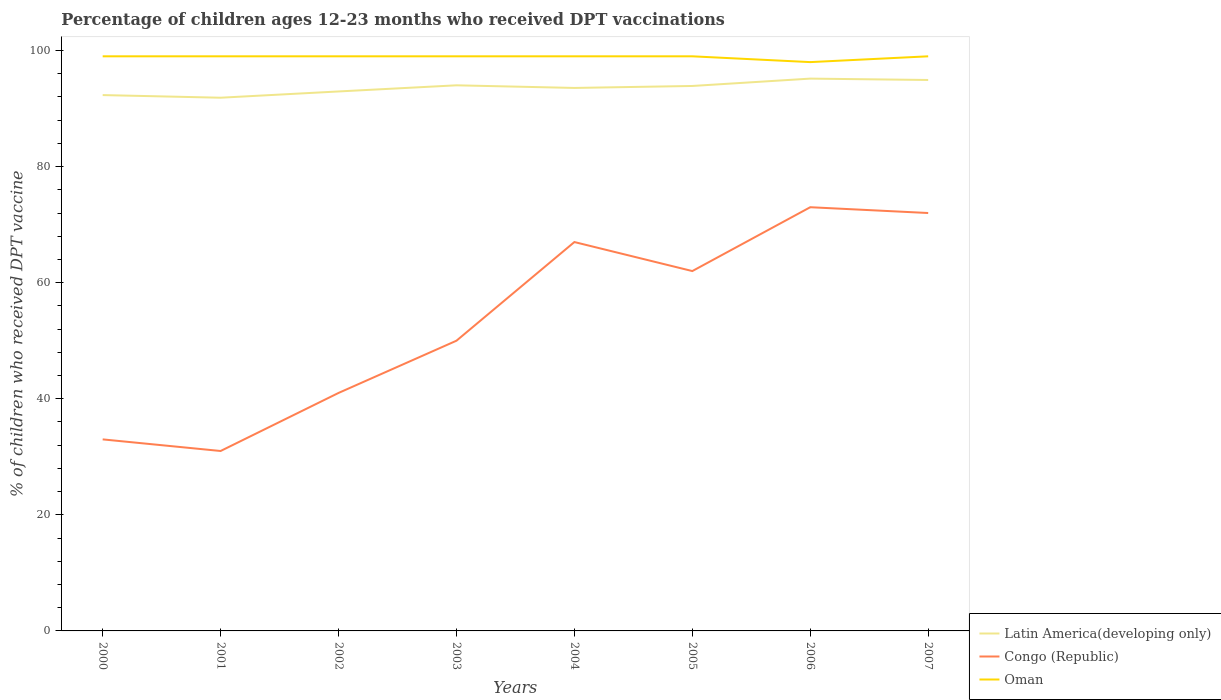Does the line corresponding to Oman intersect with the line corresponding to Latin America(developing only)?
Your response must be concise. No. Is the number of lines equal to the number of legend labels?
Provide a short and direct response. Yes. Across all years, what is the maximum percentage of children who received DPT vaccination in Latin America(developing only)?
Your answer should be very brief. 91.87. In which year was the percentage of children who received DPT vaccination in Congo (Republic) maximum?
Offer a very short reply. 2001. What is the total percentage of children who received DPT vaccination in Oman in the graph?
Provide a succinct answer. 0. What is the difference between the highest and the second highest percentage of children who received DPT vaccination in Congo (Republic)?
Offer a very short reply. 42. Is the percentage of children who received DPT vaccination in Congo (Republic) strictly greater than the percentage of children who received DPT vaccination in Oman over the years?
Your answer should be very brief. Yes. Where does the legend appear in the graph?
Your response must be concise. Bottom right. How many legend labels are there?
Your response must be concise. 3. How are the legend labels stacked?
Offer a terse response. Vertical. What is the title of the graph?
Offer a terse response. Percentage of children ages 12-23 months who received DPT vaccinations. What is the label or title of the X-axis?
Ensure brevity in your answer.  Years. What is the label or title of the Y-axis?
Make the answer very short. % of children who received DPT vaccine. What is the % of children who received DPT vaccine of Latin America(developing only) in 2000?
Keep it short and to the point. 92.32. What is the % of children who received DPT vaccine of Latin America(developing only) in 2001?
Keep it short and to the point. 91.87. What is the % of children who received DPT vaccine in Congo (Republic) in 2001?
Your answer should be very brief. 31. What is the % of children who received DPT vaccine in Oman in 2001?
Keep it short and to the point. 99. What is the % of children who received DPT vaccine of Latin America(developing only) in 2002?
Offer a very short reply. 92.95. What is the % of children who received DPT vaccine in Congo (Republic) in 2002?
Offer a very short reply. 41. What is the % of children who received DPT vaccine of Latin America(developing only) in 2003?
Ensure brevity in your answer.  94. What is the % of children who received DPT vaccine in Congo (Republic) in 2003?
Your answer should be very brief. 50. What is the % of children who received DPT vaccine of Latin America(developing only) in 2004?
Your response must be concise. 93.55. What is the % of children who received DPT vaccine of Congo (Republic) in 2004?
Ensure brevity in your answer.  67. What is the % of children who received DPT vaccine of Oman in 2004?
Your answer should be very brief. 99. What is the % of children who received DPT vaccine of Latin America(developing only) in 2005?
Your answer should be very brief. 93.89. What is the % of children who received DPT vaccine of Latin America(developing only) in 2006?
Your answer should be compact. 95.16. What is the % of children who received DPT vaccine in Congo (Republic) in 2006?
Keep it short and to the point. 73. What is the % of children who received DPT vaccine of Latin America(developing only) in 2007?
Make the answer very short. 94.92. What is the % of children who received DPT vaccine in Congo (Republic) in 2007?
Provide a succinct answer. 72. Across all years, what is the maximum % of children who received DPT vaccine of Latin America(developing only)?
Give a very brief answer. 95.16. Across all years, what is the maximum % of children who received DPT vaccine in Congo (Republic)?
Your answer should be very brief. 73. Across all years, what is the maximum % of children who received DPT vaccine of Oman?
Give a very brief answer. 99. Across all years, what is the minimum % of children who received DPT vaccine in Latin America(developing only)?
Offer a very short reply. 91.87. What is the total % of children who received DPT vaccine in Latin America(developing only) in the graph?
Ensure brevity in your answer.  748.66. What is the total % of children who received DPT vaccine of Congo (Republic) in the graph?
Ensure brevity in your answer.  429. What is the total % of children who received DPT vaccine of Oman in the graph?
Give a very brief answer. 791. What is the difference between the % of children who received DPT vaccine in Latin America(developing only) in 2000 and that in 2001?
Your response must be concise. 0.45. What is the difference between the % of children who received DPT vaccine of Congo (Republic) in 2000 and that in 2001?
Keep it short and to the point. 2. What is the difference between the % of children who received DPT vaccine in Oman in 2000 and that in 2001?
Offer a terse response. 0. What is the difference between the % of children who received DPT vaccine of Latin America(developing only) in 2000 and that in 2002?
Provide a succinct answer. -0.62. What is the difference between the % of children who received DPT vaccine in Congo (Republic) in 2000 and that in 2002?
Your response must be concise. -8. What is the difference between the % of children who received DPT vaccine of Latin America(developing only) in 2000 and that in 2003?
Make the answer very short. -1.68. What is the difference between the % of children who received DPT vaccine in Oman in 2000 and that in 2003?
Offer a very short reply. 0. What is the difference between the % of children who received DPT vaccine of Latin America(developing only) in 2000 and that in 2004?
Provide a short and direct response. -1.23. What is the difference between the % of children who received DPT vaccine in Congo (Republic) in 2000 and that in 2004?
Your answer should be compact. -34. What is the difference between the % of children who received DPT vaccine of Latin America(developing only) in 2000 and that in 2005?
Provide a succinct answer. -1.57. What is the difference between the % of children who received DPT vaccine in Congo (Republic) in 2000 and that in 2005?
Keep it short and to the point. -29. What is the difference between the % of children who received DPT vaccine of Oman in 2000 and that in 2005?
Your response must be concise. 0. What is the difference between the % of children who received DPT vaccine of Latin America(developing only) in 2000 and that in 2006?
Your response must be concise. -2.84. What is the difference between the % of children who received DPT vaccine in Oman in 2000 and that in 2006?
Make the answer very short. 1. What is the difference between the % of children who received DPT vaccine in Latin America(developing only) in 2000 and that in 2007?
Your answer should be compact. -2.6. What is the difference between the % of children who received DPT vaccine in Congo (Republic) in 2000 and that in 2007?
Provide a succinct answer. -39. What is the difference between the % of children who received DPT vaccine of Latin America(developing only) in 2001 and that in 2002?
Give a very brief answer. -1.08. What is the difference between the % of children who received DPT vaccine of Oman in 2001 and that in 2002?
Your answer should be very brief. 0. What is the difference between the % of children who received DPT vaccine of Latin America(developing only) in 2001 and that in 2003?
Your answer should be compact. -2.14. What is the difference between the % of children who received DPT vaccine of Oman in 2001 and that in 2003?
Offer a very short reply. 0. What is the difference between the % of children who received DPT vaccine of Latin America(developing only) in 2001 and that in 2004?
Make the answer very short. -1.68. What is the difference between the % of children who received DPT vaccine of Congo (Republic) in 2001 and that in 2004?
Give a very brief answer. -36. What is the difference between the % of children who received DPT vaccine of Oman in 2001 and that in 2004?
Offer a very short reply. 0. What is the difference between the % of children who received DPT vaccine in Latin America(developing only) in 2001 and that in 2005?
Give a very brief answer. -2.02. What is the difference between the % of children who received DPT vaccine in Congo (Republic) in 2001 and that in 2005?
Your answer should be very brief. -31. What is the difference between the % of children who received DPT vaccine of Latin America(developing only) in 2001 and that in 2006?
Offer a terse response. -3.29. What is the difference between the % of children who received DPT vaccine of Congo (Republic) in 2001 and that in 2006?
Offer a terse response. -42. What is the difference between the % of children who received DPT vaccine in Oman in 2001 and that in 2006?
Provide a succinct answer. 1. What is the difference between the % of children who received DPT vaccine in Latin America(developing only) in 2001 and that in 2007?
Keep it short and to the point. -3.05. What is the difference between the % of children who received DPT vaccine of Congo (Republic) in 2001 and that in 2007?
Give a very brief answer. -41. What is the difference between the % of children who received DPT vaccine in Latin America(developing only) in 2002 and that in 2003?
Offer a very short reply. -1.06. What is the difference between the % of children who received DPT vaccine in Congo (Republic) in 2002 and that in 2003?
Your answer should be very brief. -9. What is the difference between the % of children who received DPT vaccine in Oman in 2002 and that in 2003?
Make the answer very short. 0. What is the difference between the % of children who received DPT vaccine in Latin America(developing only) in 2002 and that in 2004?
Your answer should be very brief. -0.61. What is the difference between the % of children who received DPT vaccine of Congo (Republic) in 2002 and that in 2004?
Offer a very short reply. -26. What is the difference between the % of children who received DPT vaccine in Oman in 2002 and that in 2004?
Make the answer very short. 0. What is the difference between the % of children who received DPT vaccine in Latin America(developing only) in 2002 and that in 2005?
Offer a very short reply. -0.95. What is the difference between the % of children who received DPT vaccine in Latin America(developing only) in 2002 and that in 2006?
Your response must be concise. -2.21. What is the difference between the % of children who received DPT vaccine in Congo (Republic) in 2002 and that in 2006?
Ensure brevity in your answer.  -32. What is the difference between the % of children who received DPT vaccine of Latin America(developing only) in 2002 and that in 2007?
Provide a succinct answer. -1.98. What is the difference between the % of children who received DPT vaccine of Congo (Republic) in 2002 and that in 2007?
Offer a terse response. -31. What is the difference between the % of children who received DPT vaccine in Latin America(developing only) in 2003 and that in 2004?
Keep it short and to the point. 0.45. What is the difference between the % of children who received DPT vaccine of Oman in 2003 and that in 2004?
Offer a terse response. 0. What is the difference between the % of children who received DPT vaccine of Latin America(developing only) in 2003 and that in 2005?
Offer a terse response. 0.11. What is the difference between the % of children who received DPT vaccine of Oman in 2003 and that in 2005?
Your answer should be very brief. 0. What is the difference between the % of children who received DPT vaccine of Latin America(developing only) in 2003 and that in 2006?
Provide a succinct answer. -1.15. What is the difference between the % of children who received DPT vaccine in Latin America(developing only) in 2003 and that in 2007?
Offer a very short reply. -0.92. What is the difference between the % of children who received DPT vaccine in Oman in 2003 and that in 2007?
Keep it short and to the point. 0. What is the difference between the % of children who received DPT vaccine of Latin America(developing only) in 2004 and that in 2005?
Provide a succinct answer. -0.34. What is the difference between the % of children who received DPT vaccine in Congo (Republic) in 2004 and that in 2005?
Keep it short and to the point. 5. What is the difference between the % of children who received DPT vaccine in Oman in 2004 and that in 2005?
Ensure brevity in your answer.  0. What is the difference between the % of children who received DPT vaccine of Latin America(developing only) in 2004 and that in 2006?
Offer a terse response. -1.61. What is the difference between the % of children who received DPT vaccine in Congo (Republic) in 2004 and that in 2006?
Offer a very short reply. -6. What is the difference between the % of children who received DPT vaccine in Latin America(developing only) in 2004 and that in 2007?
Provide a short and direct response. -1.37. What is the difference between the % of children who received DPT vaccine of Congo (Republic) in 2004 and that in 2007?
Ensure brevity in your answer.  -5. What is the difference between the % of children who received DPT vaccine in Latin America(developing only) in 2005 and that in 2006?
Ensure brevity in your answer.  -1.27. What is the difference between the % of children who received DPT vaccine of Congo (Republic) in 2005 and that in 2006?
Your response must be concise. -11. What is the difference between the % of children who received DPT vaccine in Oman in 2005 and that in 2006?
Make the answer very short. 1. What is the difference between the % of children who received DPT vaccine of Latin America(developing only) in 2005 and that in 2007?
Your answer should be compact. -1.03. What is the difference between the % of children who received DPT vaccine of Oman in 2005 and that in 2007?
Offer a terse response. 0. What is the difference between the % of children who received DPT vaccine in Latin America(developing only) in 2006 and that in 2007?
Provide a short and direct response. 0.24. What is the difference between the % of children who received DPT vaccine in Congo (Republic) in 2006 and that in 2007?
Keep it short and to the point. 1. What is the difference between the % of children who received DPT vaccine of Oman in 2006 and that in 2007?
Give a very brief answer. -1. What is the difference between the % of children who received DPT vaccine in Latin America(developing only) in 2000 and the % of children who received DPT vaccine in Congo (Republic) in 2001?
Your response must be concise. 61.32. What is the difference between the % of children who received DPT vaccine of Latin America(developing only) in 2000 and the % of children who received DPT vaccine of Oman in 2001?
Offer a very short reply. -6.68. What is the difference between the % of children who received DPT vaccine in Congo (Republic) in 2000 and the % of children who received DPT vaccine in Oman in 2001?
Your answer should be compact. -66. What is the difference between the % of children who received DPT vaccine of Latin America(developing only) in 2000 and the % of children who received DPT vaccine of Congo (Republic) in 2002?
Offer a very short reply. 51.32. What is the difference between the % of children who received DPT vaccine in Latin America(developing only) in 2000 and the % of children who received DPT vaccine in Oman in 2002?
Ensure brevity in your answer.  -6.68. What is the difference between the % of children who received DPT vaccine in Congo (Republic) in 2000 and the % of children who received DPT vaccine in Oman in 2002?
Provide a succinct answer. -66. What is the difference between the % of children who received DPT vaccine of Latin America(developing only) in 2000 and the % of children who received DPT vaccine of Congo (Republic) in 2003?
Your answer should be compact. 42.32. What is the difference between the % of children who received DPT vaccine in Latin America(developing only) in 2000 and the % of children who received DPT vaccine in Oman in 2003?
Your response must be concise. -6.68. What is the difference between the % of children who received DPT vaccine in Congo (Republic) in 2000 and the % of children who received DPT vaccine in Oman in 2003?
Your answer should be compact. -66. What is the difference between the % of children who received DPT vaccine in Latin America(developing only) in 2000 and the % of children who received DPT vaccine in Congo (Republic) in 2004?
Keep it short and to the point. 25.32. What is the difference between the % of children who received DPT vaccine in Latin America(developing only) in 2000 and the % of children who received DPT vaccine in Oman in 2004?
Offer a terse response. -6.68. What is the difference between the % of children who received DPT vaccine of Congo (Republic) in 2000 and the % of children who received DPT vaccine of Oman in 2004?
Your answer should be compact. -66. What is the difference between the % of children who received DPT vaccine in Latin America(developing only) in 2000 and the % of children who received DPT vaccine in Congo (Republic) in 2005?
Offer a terse response. 30.32. What is the difference between the % of children who received DPT vaccine of Latin America(developing only) in 2000 and the % of children who received DPT vaccine of Oman in 2005?
Offer a terse response. -6.68. What is the difference between the % of children who received DPT vaccine in Congo (Republic) in 2000 and the % of children who received DPT vaccine in Oman in 2005?
Your answer should be compact. -66. What is the difference between the % of children who received DPT vaccine of Latin America(developing only) in 2000 and the % of children who received DPT vaccine of Congo (Republic) in 2006?
Provide a succinct answer. 19.32. What is the difference between the % of children who received DPT vaccine in Latin America(developing only) in 2000 and the % of children who received DPT vaccine in Oman in 2006?
Your answer should be compact. -5.68. What is the difference between the % of children who received DPT vaccine of Congo (Republic) in 2000 and the % of children who received DPT vaccine of Oman in 2006?
Make the answer very short. -65. What is the difference between the % of children who received DPT vaccine of Latin America(developing only) in 2000 and the % of children who received DPT vaccine of Congo (Republic) in 2007?
Make the answer very short. 20.32. What is the difference between the % of children who received DPT vaccine in Latin America(developing only) in 2000 and the % of children who received DPT vaccine in Oman in 2007?
Ensure brevity in your answer.  -6.68. What is the difference between the % of children who received DPT vaccine of Congo (Republic) in 2000 and the % of children who received DPT vaccine of Oman in 2007?
Make the answer very short. -66. What is the difference between the % of children who received DPT vaccine in Latin America(developing only) in 2001 and the % of children who received DPT vaccine in Congo (Republic) in 2002?
Your response must be concise. 50.87. What is the difference between the % of children who received DPT vaccine of Latin America(developing only) in 2001 and the % of children who received DPT vaccine of Oman in 2002?
Provide a succinct answer. -7.13. What is the difference between the % of children who received DPT vaccine in Congo (Republic) in 2001 and the % of children who received DPT vaccine in Oman in 2002?
Your answer should be very brief. -68. What is the difference between the % of children who received DPT vaccine of Latin America(developing only) in 2001 and the % of children who received DPT vaccine of Congo (Republic) in 2003?
Give a very brief answer. 41.87. What is the difference between the % of children who received DPT vaccine of Latin America(developing only) in 2001 and the % of children who received DPT vaccine of Oman in 2003?
Your answer should be very brief. -7.13. What is the difference between the % of children who received DPT vaccine of Congo (Republic) in 2001 and the % of children who received DPT vaccine of Oman in 2003?
Your response must be concise. -68. What is the difference between the % of children who received DPT vaccine of Latin America(developing only) in 2001 and the % of children who received DPT vaccine of Congo (Republic) in 2004?
Keep it short and to the point. 24.87. What is the difference between the % of children who received DPT vaccine of Latin America(developing only) in 2001 and the % of children who received DPT vaccine of Oman in 2004?
Provide a short and direct response. -7.13. What is the difference between the % of children who received DPT vaccine of Congo (Republic) in 2001 and the % of children who received DPT vaccine of Oman in 2004?
Keep it short and to the point. -68. What is the difference between the % of children who received DPT vaccine in Latin America(developing only) in 2001 and the % of children who received DPT vaccine in Congo (Republic) in 2005?
Your response must be concise. 29.87. What is the difference between the % of children who received DPT vaccine of Latin America(developing only) in 2001 and the % of children who received DPT vaccine of Oman in 2005?
Your answer should be very brief. -7.13. What is the difference between the % of children who received DPT vaccine in Congo (Republic) in 2001 and the % of children who received DPT vaccine in Oman in 2005?
Offer a terse response. -68. What is the difference between the % of children who received DPT vaccine in Latin America(developing only) in 2001 and the % of children who received DPT vaccine in Congo (Republic) in 2006?
Provide a succinct answer. 18.87. What is the difference between the % of children who received DPT vaccine in Latin America(developing only) in 2001 and the % of children who received DPT vaccine in Oman in 2006?
Provide a succinct answer. -6.13. What is the difference between the % of children who received DPT vaccine in Congo (Republic) in 2001 and the % of children who received DPT vaccine in Oman in 2006?
Your answer should be compact. -67. What is the difference between the % of children who received DPT vaccine in Latin America(developing only) in 2001 and the % of children who received DPT vaccine in Congo (Republic) in 2007?
Make the answer very short. 19.87. What is the difference between the % of children who received DPT vaccine in Latin America(developing only) in 2001 and the % of children who received DPT vaccine in Oman in 2007?
Ensure brevity in your answer.  -7.13. What is the difference between the % of children who received DPT vaccine in Congo (Republic) in 2001 and the % of children who received DPT vaccine in Oman in 2007?
Provide a succinct answer. -68. What is the difference between the % of children who received DPT vaccine of Latin America(developing only) in 2002 and the % of children who received DPT vaccine of Congo (Republic) in 2003?
Keep it short and to the point. 42.95. What is the difference between the % of children who received DPT vaccine of Latin America(developing only) in 2002 and the % of children who received DPT vaccine of Oman in 2003?
Keep it short and to the point. -6.05. What is the difference between the % of children who received DPT vaccine in Congo (Republic) in 2002 and the % of children who received DPT vaccine in Oman in 2003?
Your answer should be very brief. -58. What is the difference between the % of children who received DPT vaccine of Latin America(developing only) in 2002 and the % of children who received DPT vaccine of Congo (Republic) in 2004?
Give a very brief answer. 25.95. What is the difference between the % of children who received DPT vaccine of Latin America(developing only) in 2002 and the % of children who received DPT vaccine of Oman in 2004?
Give a very brief answer. -6.05. What is the difference between the % of children who received DPT vaccine of Congo (Republic) in 2002 and the % of children who received DPT vaccine of Oman in 2004?
Your answer should be compact. -58. What is the difference between the % of children who received DPT vaccine of Latin America(developing only) in 2002 and the % of children who received DPT vaccine of Congo (Republic) in 2005?
Offer a terse response. 30.95. What is the difference between the % of children who received DPT vaccine of Latin America(developing only) in 2002 and the % of children who received DPT vaccine of Oman in 2005?
Offer a terse response. -6.05. What is the difference between the % of children who received DPT vaccine in Congo (Republic) in 2002 and the % of children who received DPT vaccine in Oman in 2005?
Give a very brief answer. -58. What is the difference between the % of children who received DPT vaccine in Latin America(developing only) in 2002 and the % of children who received DPT vaccine in Congo (Republic) in 2006?
Provide a short and direct response. 19.95. What is the difference between the % of children who received DPT vaccine of Latin America(developing only) in 2002 and the % of children who received DPT vaccine of Oman in 2006?
Your response must be concise. -5.05. What is the difference between the % of children who received DPT vaccine in Congo (Republic) in 2002 and the % of children who received DPT vaccine in Oman in 2006?
Ensure brevity in your answer.  -57. What is the difference between the % of children who received DPT vaccine of Latin America(developing only) in 2002 and the % of children who received DPT vaccine of Congo (Republic) in 2007?
Give a very brief answer. 20.95. What is the difference between the % of children who received DPT vaccine in Latin America(developing only) in 2002 and the % of children who received DPT vaccine in Oman in 2007?
Provide a succinct answer. -6.05. What is the difference between the % of children who received DPT vaccine of Congo (Republic) in 2002 and the % of children who received DPT vaccine of Oman in 2007?
Provide a short and direct response. -58. What is the difference between the % of children who received DPT vaccine of Latin America(developing only) in 2003 and the % of children who received DPT vaccine of Congo (Republic) in 2004?
Give a very brief answer. 27. What is the difference between the % of children who received DPT vaccine in Latin America(developing only) in 2003 and the % of children who received DPT vaccine in Oman in 2004?
Provide a short and direct response. -5. What is the difference between the % of children who received DPT vaccine of Congo (Republic) in 2003 and the % of children who received DPT vaccine of Oman in 2004?
Your answer should be compact. -49. What is the difference between the % of children who received DPT vaccine of Latin America(developing only) in 2003 and the % of children who received DPT vaccine of Congo (Republic) in 2005?
Your answer should be compact. 32. What is the difference between the % of children who received DPT vaccine in Latin America(developing only) in 2003 and the % of children who received DPT vaccine in Oman in 2005?
Make the answer very short. -5. What is the difference between the % of children who received DPT vaccine of Congo (Republic) in 2003 and the % of children who received DPT vaccine of Oman in 2005?
Provide a succinct answer. -49. What is the difference between the % of children who received DPT vaccine in Latin America(developing only) in 2003 and the % of children who received DPT vaccine in Congo (Republic) in 2006?
Provide a succinct answer. 21. What is the difference between the % of children who received DPT vaccine in Latin America(developing only) in 2003 and the % of children who received DPT vaccine in Oman in 2006?
Offer a terse response. -4. What is the difference between the % of children who received DPT vaccine in Congo (Republic) in 2003 and the % of children who received DPT vaccine in Oman in 2006?
Offer a terse response. -48. What is the difference between the % of children who received DPT vaccine of Latin America(developing only) in 2003 and the % of children who received DPT vaccine of Congo (Republic) in 2007?
Provide a short and direct response. 22. What is the difference between the % of children who received DPT vaccine of Latin America(developing only) in 2003 and the % of children who received DPT vaccine of Oman in 2007?
Your response must be concise. -5. What is the difference between the % of children who received DPT vaccine in Congo (Republic) in 2003 and the % of children who received DPT vaccine in Oman in 2007?
Offer a very short reply. -49. What is the difference between the % of children who received DPT vaccine in Latin America(developing only) in 2004 and the % of children who received DPT vaccine in Congo (Republic) in 2005?
Provide a succinct answer. 31.55. What is the difference between the % of children who received DPT vaccine in Latin America(developing only) in 2004 and the % of children who received DPT vaccine in Oman in 2005?
Offer a terse response. -5.45. What is the difference between the % of children who received DPT vaccine in Congo (Republic) in 2004 and the % of children who received DPT vaccine in Oman in 2005?
Offer a terse response. -32. What is the difference between the % of children who received DPT vaccine of Latin America(developing only) in 2004 and the % of children who received DPT vaccine of Congo (Republic) in 2006?
Offer a very short reply. 20.55. What is the difference between the % of children who received DPT vaccine in Latin America(developing only) in 2004 and the % of children who received DPT vaccine in Oman in 2006?
Your answer should be compact. -4.45. What is the difference between the % of children who received DPT vaccine of Congo (Republic) in 2004 and the % of children who received DPT vaccine of Oman in 2006?
Your answer should be very brief. -31. What is the difference between the % of children who received DPT vaccine in Latin America(developing only) in 2004 and the % of children who received DPT vaccine in Congo (Republic) in 2007?
Make the answer very short. 21.55. What is the difference between the % of children who received DPT vaccine of Latin America(developing only) in 2004 and the % of children who received DPT vaccine of Oman in 2007?
Keep it short and to the point. -5.45. What is the difference between the % of children who received DPT vaccine in Congo (Republic) in 2004 and the % of children who received DPT vaccine in Oman in 2007?
Ensure brevity in your answer.  -32. What is the difference between the % of children who received DPT vaccine in Latin America(developing only) in 2005 and the % of children who received DPT vaccine in Congo (Republic) in 2006?
Provide a succinct answer. 20.89. What is the difference between the % of children who received DPT vaccine of Latin America(developing only) in 2005 and the % of children who received DPT vaccine of Oman in 2006?
Give a very brief answer. -4.11. What is the difference between the % of children who received DPT vaccine in Congo (Republic) in 2005 and the % of children who received DPT vaccine in Oman in 2006?
Give a very brief answer. -36. What is the difference between the % of children who received DPT vaccine in Latin America(developing only) in 2005 and the % of children who received DPT vaccine in Congo (Republic) in 2007?
Your response must be concise. 21.89. What is the difference between the % of children who received DPT vaccine of Latin America(developing only) in 2005 and the % of children who received DPT vaccine of Oman in 2007?
Provide a succinct answer. -5.11. What is the difference between the % of children who received DPT vaccine in Congo (Republic) in 2005 and the % of children who received DPT vaccine in Oman in 2007?
Keep it short and to the point. -37. What is the difference between the % of children who received DPT vaccine of Latin America(developing only) in 2006 and the % of children who received DPT vaccine of Congo (Republic) in 2007?
Make the answer very short. 23.16. What is the difference between the % of children who received DPT vaccine of Latin America(developing only) in 2006 and the % of children who received DPT vaccine of Oman in 2007?
Keep it short and to the point. -3.84. What is the average % of children who received DPT vaccine in Latin America(developing only) per year?
Ensure brevity in your answer.  93.58. What is the average % of children who received DPT vaccine in Congo (Republic) per year?
Your answer should be very brief. 53.62. What is the average % of children who received DPT vaccine in Oman per year?
Make the answer very short. 98.88. In the year 2000, what is the difference between the % of children who received DPT vaccine of Latin America(developing only) and % of children who received DPT vaccine of Congo (Republic)?
Provide a short and direct response. 59.32. In the year 2000, what is the difference between the % of children who received DPT vaccine in Latin America(developing only) and % of children who received DPT vaccine in Oman?
Offer a very short reply. -6.68. In the year 2000, what is the difference between the % of children who received DPT vaccine of Congo (Republic) and % of children who received DPT vaccine of Oman?
Make the answer very short. -66. In the year 2001, what is the difference between the % of children who received DPT vaccine of Latin America(developing only) and % of children who received DPT vaccine of Congo (Republic)?
Offer a very short reply. 60.87. In the year 2001, what is the difference between the % of children who received DPT vaccine in Latin America(developing only) and % of children who received DPT vaccine in Oman?
Your answer should be compact. -7.13. In the year 2001, what is the difference between the % of children who received DPT vaccine in Congo (Republic) and % of children who received DPT vaccine in Oman?
Your response must be concise. -68. In the year 2002, what is the difference between the % of children who received DPT vaccine of Latin America(developing only) and % of children who received DPT vaccine of Congo (Republic)?
Offer a terse response. 51.95. In the year 2002, what is the difference between the % of children who received DPT vaccine in Latin America(developing only) and % of children who received DPT vaccine in Oman?
Give a very brief answer. -6.05. In the year 2002, what is the difference between the % of children who received DPT vaccine of Congo (Republic) and % of children who received DPT vaccine of Oman?
Offer a terse response. -58. In the year 2003, what is the difference between the % of children who received DPT vaccine of Latin America(developing only) and % of children who received DPT vaccine of Congo (Republic)?
Provide a short and direct response. 44. In the year 2003, what is the difference between the % of children who received DPT vaccine in Latin America(developing only) and % of children who received DPT vaccine in Oman?
Make the answer very short. -5. In the year 2003, what is the difference between the % of children who received DPT vaccine of Congo (Republic) and % of children who received DPT vaccine of Oman?
Provide a short and direct response. -49. In the year 2004, what is the difference between the % of children who received DPT vaccine in Latin America(developing only) and % of children who received DPT vaccine in Congo (Republic)?
Give a very brief answer. 26.55. In the year 2004, what is the difference between the % of children who received DPT vaccine in Latin America(developing only) and % of children who received DPT vaccine in Oman?
Make the answer very short. -5.45. In the year 2004, what is the difference between the % of children who received DPT vaccine in Congo (Republic) and % of children who received DPT vaccine in Oman?
Provide a succinct answer. -32. In the year 2005, what is the difference between the % of children who received DPT vaccine in Latin America(developing only) and % of children who received DPT vaccine in Congo (Republic)?
Provide a succinct answer. 31.89. In the year 2005, what is the difference between the % of children who received DPT vaccine of Latin America(developing only) and % of children who received DPT vaccine of Oman?
Give a very brief answer. -5.11. In the year 2005, what is the difference between the % of children who received DPT vaccine of Congo (Republic) and % of children who received DPT vaccine of Oman?
Keep it short and to the point. -37. In the year 2006, what is the difference between the % of children who received DPT vaccine of Latin America(developing only) and % of children who received DPT vaccine of Congo (Republic)?
Make the answer very short. 22.16. In the year 2006, what is the difference between the % of children who received DPT vaccine in Latin America(developing only) and % of children who received DPT vaccine in Oman?
Provide a short and direct response. -2.84. In the year 2007, what is the difference between the % of children who received DPT vaccine of Latin America(developing only) and % of children who received DPT vaccine of Congo (Republic)?
Ensure brevity in your answer.  22.92. In the year 2007, what is the difference between the % of children who received DPT vaccine of Latin America(developing only) and % of children who received DPT vaccine of Oman?
Your answer should be compact. -4.08. In the year 2007, what is the difference between the % of children who received DPT vaccine in Congo (Republic) and % of children who received DPT vaccine in Oman?
Your answer should be compact. -27. What is the ratio of the % of children who received DPT vaccine of Congo (Republic) in 2000 to that in 2001?
Your answer should be compact. 1.06. What is the ratio of the % of children who received DPT vaccine of Latin America(developing only) in 2000 to that in 2002?
Your response must be concise. 0.99. What is the ratio of the % of children who received DPT vaccine in Congo (Republic) in 2000 to that in 2002?
Your answer should be compact. 0.8. What is the ratio of the % of children who received DPT vaccine of Latin America(developing only) in 2000 to that in 2003?
Ensure brevity in your answer.  0.98. What is the ratio of the % of children who received DPT vaccine in Congo (Republic) in 2000 to that in 2003?
Offer a terse response. 0.66. What is the ratio of the % of children who received DPT vaccine of Latin America(developing only) in 2000 to that in 2004?
Ensure brevity in your answer.  0.99. What is the ratio of the % of children who received DPT vaccine in Congo (Republic) in 2000 to that in 2004?
Offer a terse response. 0.49. What is the ratio of the % of children who received DPT vaccine in Latin America(developing only) in 2000 to that in 2005?
Provide a short and direct response. 0.98. What is the ratio of the % of children who received DPT vaccine in Congo (Republic) in 2000 to that in 2005?
Offer a terse response. 0.53. What is the ratio of the % of children who received DPT vaccine of Oman in 2000 to that in 2005?
Provide a short and direct response. 1. What is the ratio of the % of children who received DPT vaccine of Latin America(developing only) in 2000 to that in 2006?
Give a very brief answer. 0.97. What is the ratio of the % of children who received DPT vaccine of Congo (Republic) in 2000 to that in 2006?
Provide a succinct answer. 0.45. What is the ratio of the % of children who received DPT vaccine of Oman in 2000 to that in 2006?
Offer a very short reply. 1.01. What is the ratio of the % of children who received DPT vaccine in Latin America(developing only) in 2000 to that in 2007?
Keep it short and to the point. 0.97. What is the ratio of the % of children who received DPT vaccine of Congo (Republic) in 2000 to that in 2007?
Your response must be concise. 0.46. What is the ratio of the % of children who received DPT vaccine in Oman in 2000 to that in 2007?
Provide a short and direct response. 1. What is the ratio of the % of children who received DPT vaccine of Latin America(developing only) in 2001 to that in 2002?
Your answer should be very brief. 0.99. What is the ratio of the % of children who received DPT vaccine in Congo (Republic) in 2001 to that in 2002?
Your answer should be very brief. 0.76. What is the ratio of the % of children who received DPT vaccine in Oman in 2001 to that in 2002?
Your answer should be compact. 1. What is the ratio of the % of children who received DPT vaccine of Latin America(developing only) in 2001 to that in 2003?
Ensure brevity in your answer.  0.98. What is the ratio of the % of children who received DPT vaccine of Congo (Republic) in 2001 to that in 2003?
Ensure brevity in your answer.  0.62. What is the ratio of the % of children who received DPT vaccine in Latin America(developing only) in 2001 to that in 2004?
Provide a short and direct response. 0.98. What is the ratio of the % of children who received DPT vaccine of Congo (Republic) in 2001 to that in 2004?
Give a very brief answer. 0.46. What is the ratio of the % of children who received DPT vaccine in Latin America(developing only) in 2001 to that in 2005?
Make the answer very short. 0.98. What is the ratio of the % of children who received DPT vaccine in Congo (Republic) in 2001 to that in 2005?
Your answer should be very brief. 0.5. What is the ratio of the % of children who received DPT vaccine of Latin America(developing only) in 2001 to that in 2006?
Offer a terse response. 0.97. What is the ratio of the % of children who received DPT vaccine in Congo (Republic) in 2001 to that in 2006?
Keep it short and to the point. 0.42. What is the ratio of the % of children who received DPT vaccine in Oman in 2001 to that in 2006?
Give a very brief answer. 1.01. What is the ratio of the % of children who received DPT vaccine in Latin America(developing only) in 2001 to that in 2007?
Your answer should be very brief. 0.97. What is the ratio of the % of children who received DPT vaccine in Congo (Republic) in 2001 to that in 2007?
Provide a succinct answer. 0.43. What is the ratio of the % of children who received DPT vaccine of Oman in 2001 to that in 2007?
Your answer should be compact. 1. What is the ratio of the % of children who received DPT vaccine in Latin America(developing only) in 2002 to that in 2003?
Your answer should be compact. 0.99. What is the ratio of the % of children who received DPT vaccine in Congo (Republic) in 2002 to that in 2003?
Offer a terse response. 0.82. What is the ratio of the % of children who received DPT vaccine in Congo (Republic) in 2002 to that in 2004?
Offer a terse response. 0.61. What is the ratio of the % of children who received DPT vaccine in Congo (Republic) in 2002 to that in 2005?
Keep it short and to the point. 0.66. What is the ratio of the % of children who received DPT vaccine of Latin America(developing only) in 2002 to that in 2006?
Give a very brief answer. 0.98. What is the ratio of the % of children who received DPT vaccine in Congo (Republic) in 2002 to that in 2006?
Give a very brief answer. 0.56. What is the ratio of the % of children who received DPT vaccine in Oman in 2002 to that in 2006?
Provide a short and direct response. 1.01. What is the ratio of the % of children who received DPT vaccine of Latin America(developing only) in 2002 to that in 2007?
Ensure brevity in your answer.  0.98. What is the ratio of the % of children who received DPT vaccine of Congo (Republic) in 2002 to that in 2007?
Keep it short and to the point. 0.57. What is the ratio of the % of children who received DPT vaccine of Oman in 2002 to that in 2007?
Offer a very short reply. 1. What is the ratio of the % of children who received DPT vaccine in Congo (Republic) in 2003 to that in 2004?
Provide a succinct answer. 0.75. What is the ratio of the % of children who received DPT vaccine in Oman in 2003 to that in 2004?
Provide a short and direct response. 1. What is the ratio of the % of children who received DPT vaccine in Latin America(developing only) in 2003 to that in 2005?
Provide a succinct answer. 1. What is the ratio of the % of children who received DPT vaccine of Congo (Republic) in 2003 to that in 2005?
Offer a terse response. 0.81. What is the ratio of the % of children who received DPT vaccine of Latin America(developing only) in 2003 to that in 2006?
Your response must be concise. 0.99. What is the ratio of the % of children who received DPT vaccine of Congo (Republic) in 2003 to that in 2006?
Ensure brevity in your answer.  0.68. What is the ratio of the % of children who received DPT vaccine in Oman in 2003 to that in 2006?
Provide a succinct answer. 1.01. What is the ratio of the % of children who received DPT vaccine in Latin America(developing only) in 2003 to that in 2007?
Provide a short and direct response. 0.99. What is the ratio of the % of children who received DPT vaccine in Congo (Republic) in 2003 to that in 2007?
Make the answer very short. 0.69. What is the ratio of the % of children who received DPT vaccine in Oman in 2003 to that in 2007?
Keep it short and to the point. 1. What is the ratio of the % of children who received DPT vaccine of Congo (Republic) in 2004 to that in 2005?
Offer a terse response. 1.08. What is the ratio of the % of children who received DPT vaccine of Oman in 2004 to that in 2005?
Offer a terse response. 1. What is the ratio of the % of children who received DPT vaccine of Latin America(developing only) in 2004 to that in 2006?
Make the answer very short. 0.98. What is the ratio of the % of children who received DPT vaccine of Congo (Republic) in 2004 to that in 2006?
Provide a succinct answer. 0.92. What is the ratio of the % of children who received DPT vaccine of Oman in 2004 to that in 2006?
Ensure brevity in your answer.  1.01. What is the ratio of the % of children who received DPT vaccine of Latin America(developing only) in 2004 to that in 2007?
Offer a terse response. 0.99. What is the ratio of the % of children who received DPT vaccine in Congo (Republic) in 2004 to that in 2007?
Give a very brief answer. 0.93. What is the ratio of the % of children who received DPT vaccine of Latin America(developing only) in 2005 to that in 2006?
Give a very brief answer. 0.99. What is the ratio of the % of children who received DPT vaccine of Congo (Republic) in 2005 to that in 2006?
Offer a terse response. 0.85. What is the ratio of the % of children who received DPT vaccine in Oman in 2005 to that in 2006?
Your answer should be compact. 1.01. What is the ratio of the % of children who received DPT vaccine in Latin America(developing only) in 2005 to that in 2007?
Ensure brevity in your answer.  0.99. What is the ratio of the % of children who received DPT vaccine in Congo (Republic) in 2005 to that in 2007?
Your answer should be compact. 0.86. What is the ratio of the % of children who received DPT vaccine in Oman in 2005 to that in 2007?
Your response must be concise. 1. What is the ratio of the % of children who received DPT vaccine in Latin America(developing only) in 2006 to that in 2007?
Give a very brief answer. 1. What is the ratio of the % of children who received DPT vaccine in Congo (Republic) in 2006 to that in 2007?
Provide a succinct answer. 1.01. What is the ratio of the % of children who received DPT vaccine of Oman in 2006 to that in 2007?
Ensure brevity in your answer.  0.99. What is the difference between the highest and the second highest % of children who received DPT vaccine in Latin America(developing only)?
Provide a succinct answer. 0.24. What is the difference between the highest and the second highest % of children who received DPT vaccine of Congo (Republic)?
Ensure brevity in your answer.  1. What is the difference between the highest and the second highest % of children who received DPT vaccine of Oman?
Make the answer very short. 0. What is the difference between the highest and the lowest % of children who received DPT vaccine of Latin America(developing only)?
Give a very brief answer. 3.29. What is the difference between the highest and the lowest % of children who received DPT vaccine of Congo (Republic)?
Your answer should be compact. 42. What is the difference between the highest and the lowest % of children who received DPT vaccine in Oman?
Make the answer very short. 1. 